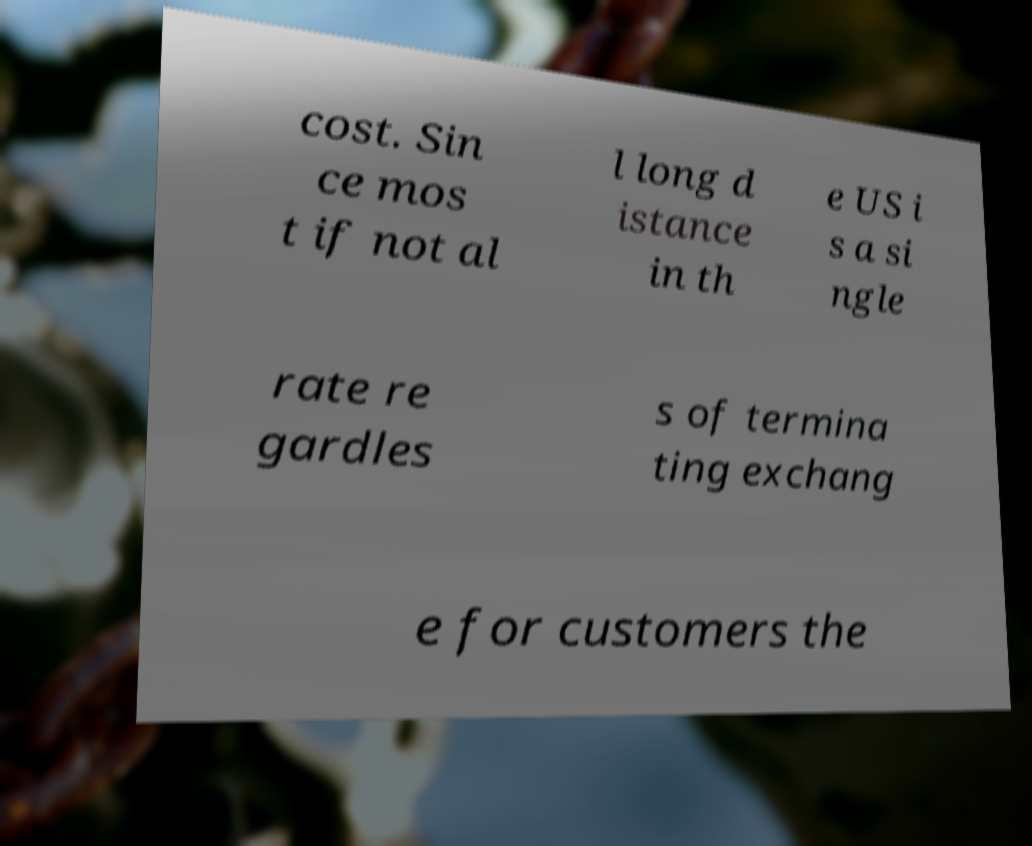Can you accurately transcribe the text from the provided image for me? cost. Sin ce mos t if not al l long d istance in th e US i s a si ngle rate re gardles s of termina ting exchang e for customers the 